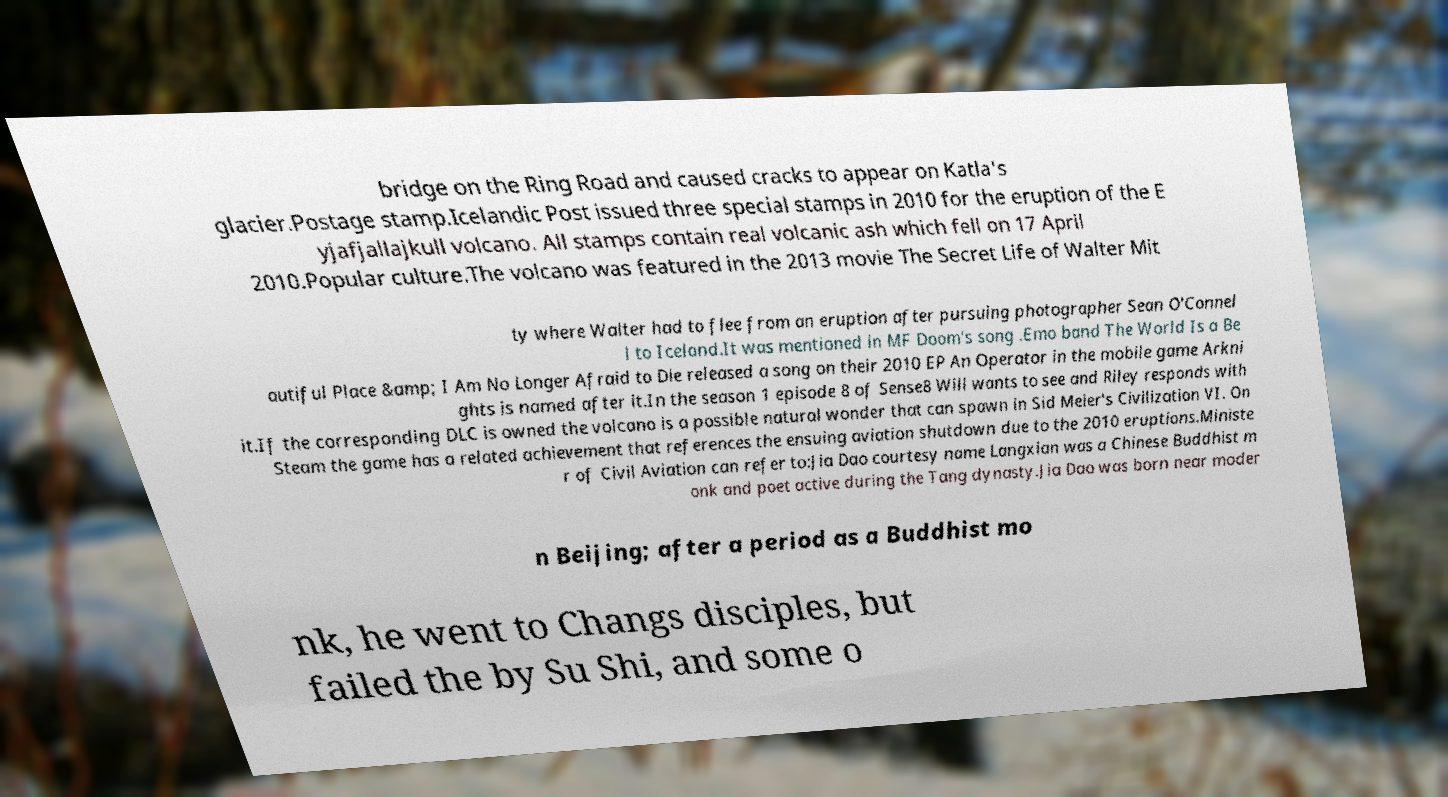Can you accurately transcribe the text from the provided image for me? bridge on the Ring Road and caused cracks to appear on Katla's glacier.Postage stamp.Icelandic Post issued three special stamps in 2010 for the eruption of the E yjafjallajkull volcano. All stamps contain real volcanic ash which fell on 17 April 2010.Popular culture.The volcano was featured in the 2013 movie The Secret Life of Walter Mit ty where Walter had to flee from an eruption after pursuing photographer Sean O'Connel l to Iceland.It was mentioned in MF Doom's song .Emo band The World Is a Be autiful Place &amp; I Am No Longer Afraid to Die released a song on their 2010 EP An Operator in the mobile game Arkni ghts is named after it.In the season 1 episode 8 of Sense8 Will wants to see and Riley responds with it.If the corresponding DLC is owned the volcano is a possible natural wonder that can spawn in Sid Meier's Civilization VI. On Steam the game has a related achievement that references the ensuing aviation shutdown due to the 2010 eruptions.Ministe r of Civil Aviation can refer to:Jia Dao courtesy name Langxian was a Chinese Buddhist m onk and poet active during the Tang dynasty.Jia Dao was born near moder n Beijing; after a period as a Buddhist mo nk, he went to Changs disciples, but failed the by Su Shi, and some o 